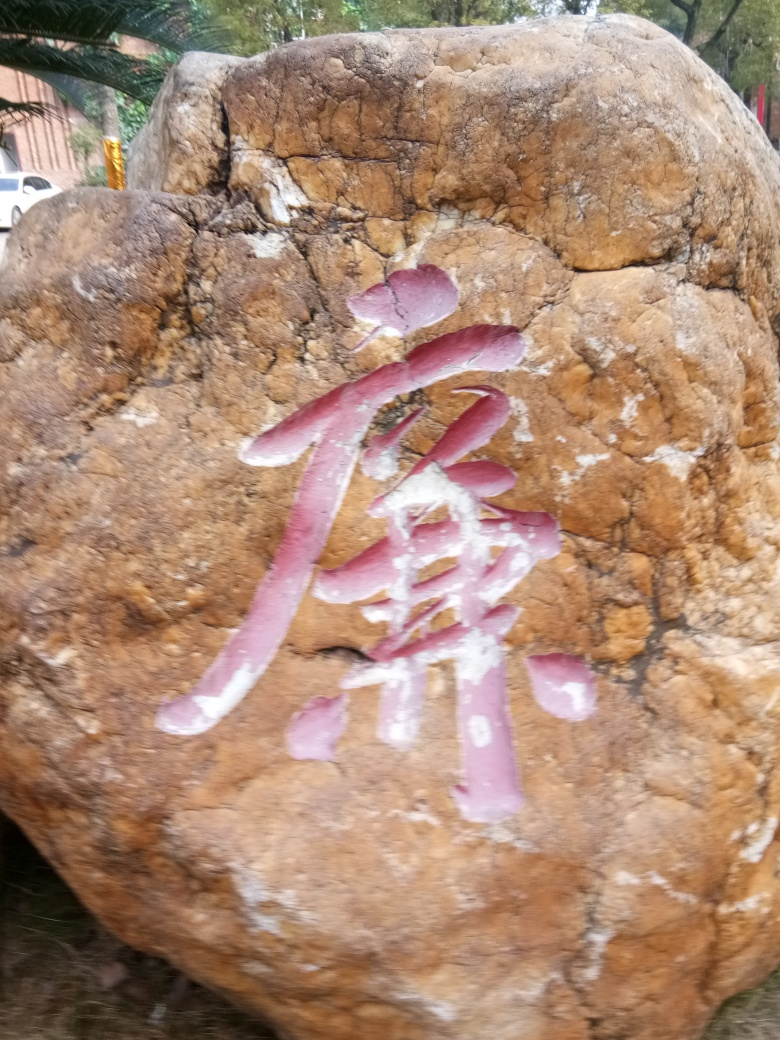What can you say about the environment surrounding the rock? From what is visible in the background, the rock is situated outdoors, possibly in a park or public space given the presence of a car and structures in the distance. Trees and greenery suggest a natural setting that is accessible to the public. 